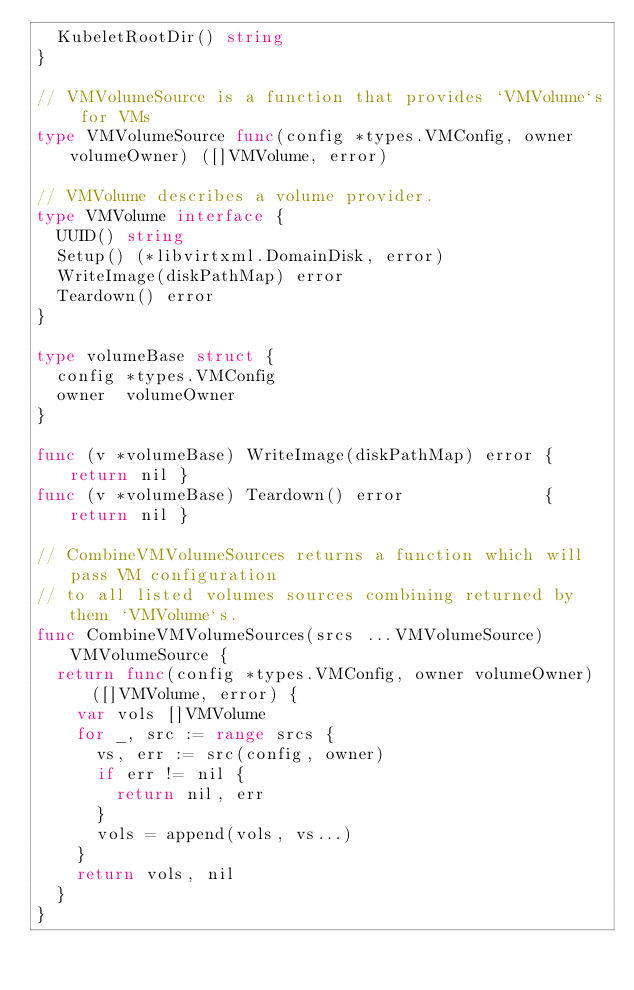<code> <loc_0><loc_0><loc_500><loc_500><_Go_>	KubeletRootDir() string
}

// VMVolumeSource is a function that provides `VMVolume`s for VMs
type VMVolumeSource func(config *types.VMConfig, owner volumeOwner) ([]VMVolume, error)

// VMVolume describes a volume provider.
type VMVolume interface {
	UUID() string
	Setup() (*libvirtxml.DomainDisk, error)
	WriteImage(diskPathMap) error
	Teardown() error
}

type volumeBase struct {
	config *types.VMConfig
	owner  volumeOwner
}

func (v *volumeBase) WriteImage(diskPathMap) error { return nil }
func (v *volumeBase) Teardown() error              { return nil }

// CombineVMVolumeSources returns a function which will pass VM configuration
// to all listed volumes sources combining returned by them `VMVolume`s.
func CombineVMVolumeSources(srcs ...VMVolumeSource) VMVolumeSource {
	return func(config *types.VMConfig, owner volumeOwner) ([]VMVolume, error) {
		var vols []VMVolume
		for _, src := range srcs {
			vs, err := src(config, owner)
			if err != nil {
				return nil, err
			}
			vols = append(vols, vs...)
		}
		return vols, nil
	}
}
</code> 